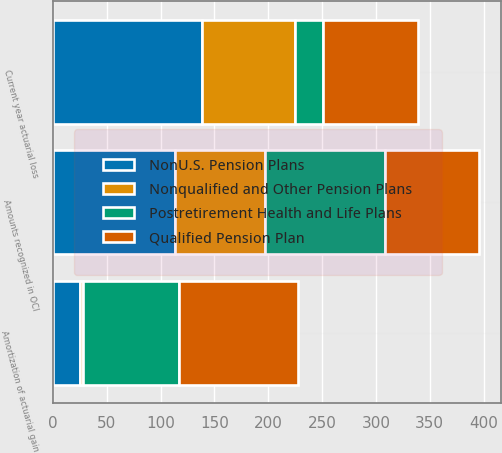Convert chart. <chart><loc_0><loc_0><loc_500><loc_500><stacked_bar_chart><ecel><fcel>Current year actuarial loss<fcel>Amortization of actuarial gain<fcel>Amounts recognized in OCI<nl><fcel>Qualified Pension Plan<fcel>88<fcel>111<fcel>88<nl><fcel>Nonqualified and Other Pension Plans<fcel>87<fcel>3<fcel>84<nl><fcel>NonU.S. Pension Plans<fcel>138<fcel>25<fcel>113<nl><fcel>Postretirement Health and Life Plans<fcel>26<fcel>89<fcel>111<nl></chart> 